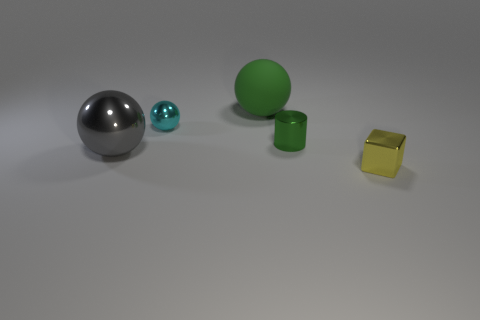Is the number of yellow metallic blocks greater than the number of large brown metal blocks?
Offer a very short reply. Yes. Is there a green rubber object that is in front of the ball that is on the right side of the small thing left of the green rubber ball?
Make the answer very short. No. What number of other things are there of the same size as the metallic block?
Keep it short and to the point. 2. There is a gray thing; are there any tiny green metallic things left of it?
Your answer should be compact. No. There is a tiny shiny sphere; does it have the same color as the large ball that is in front of the big green ball?
Your answer should be very brief. No. There is a ball in front of the small shiny thing that is left of the big sphere behind the large metal thing; what color is it?
Offer a terse response. Gray. Is there a big yellow thing of the same shape as the gray shiny object?
Provide a succinct answer. No. What color is the ball that is the same size as the rubber thing?
Provide a succinct answer. Gray. There is a large ball in front of the tiny green metal object; what material is it?
Your answer should be very brief. Metal. There is a small metal object that is left of the green matte sphere; is it the same shape as the thing that is on the left side of the small cyan sphere?
Keep it short and to the point. Yes. 